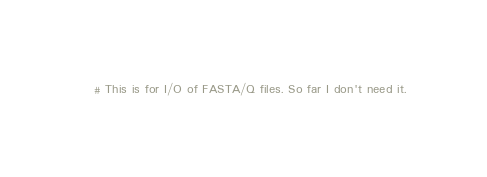<code> <loc_0><loc_0><loc_500><loc_500><_Ruby_># This is for I/O of FASTA/Q files. So far I don't need it.</code> 